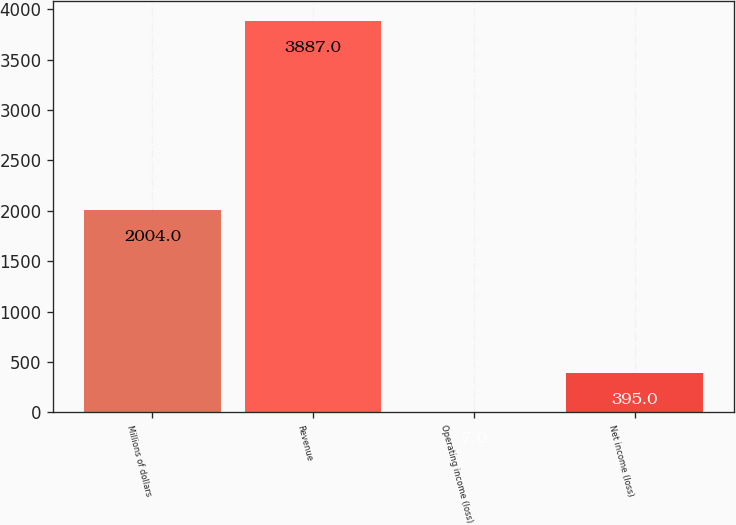Convert chart. <chart><loc_0><loc_0><loc_500><loc_500><bar_chart><fcel>Millions of dollars<fcel>Revenue<fcel>Operating income (loss)<fcel>Net income (loss)<nl><fcel>2004<fcel>3887<fcel>7<fcel>395<nl></chart> 